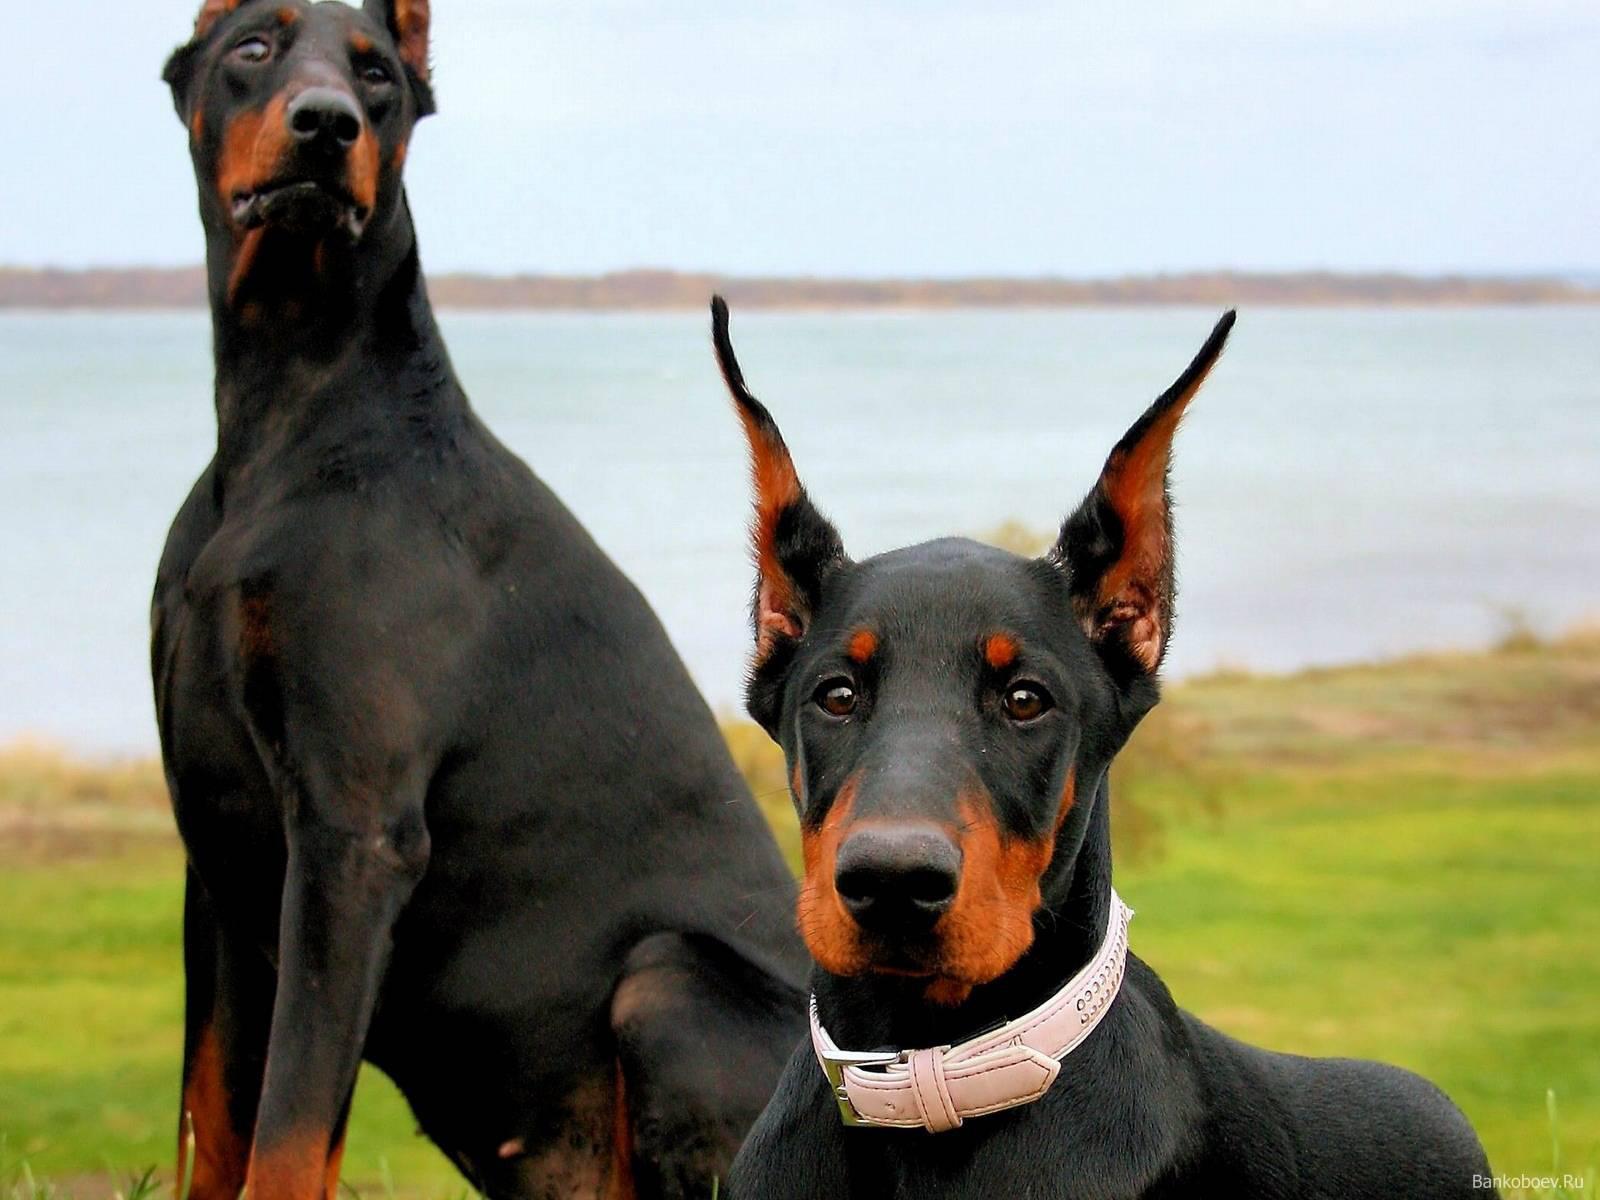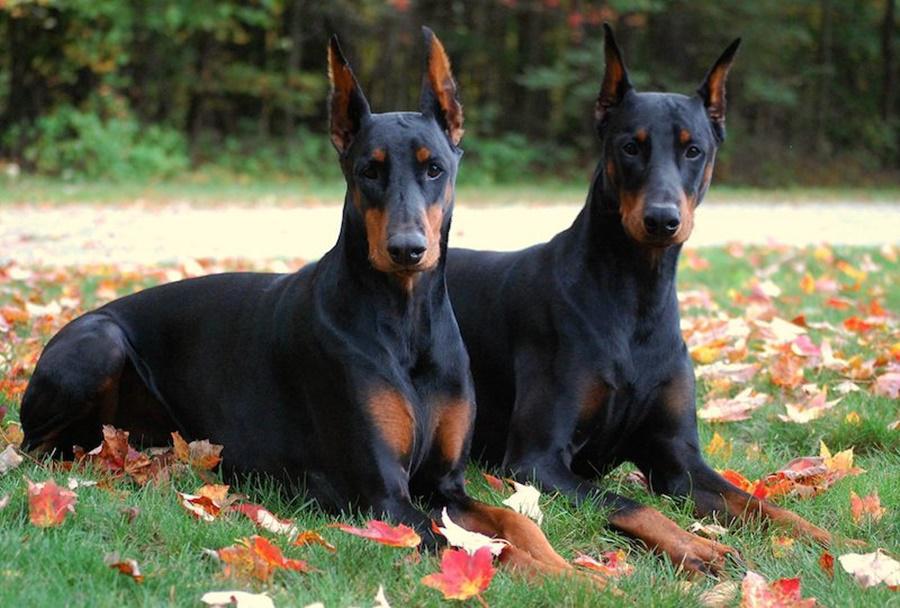The first image is the image on the left, the second image is the image on the right. Given the left and right images, does the statement "There are a total of 4 dogs sitting in pairs." hold true? Answer yes or no. Yes. The first image is the image on the left, the second image is the image on the right. Considering the images on both sides, is "There is one dog without a collar" valid? Answer yes or no. No. 